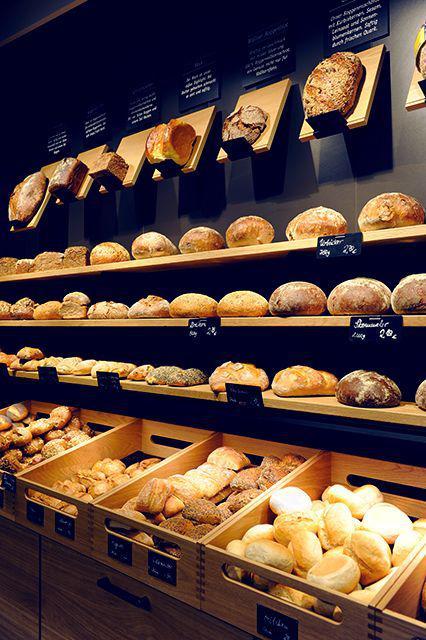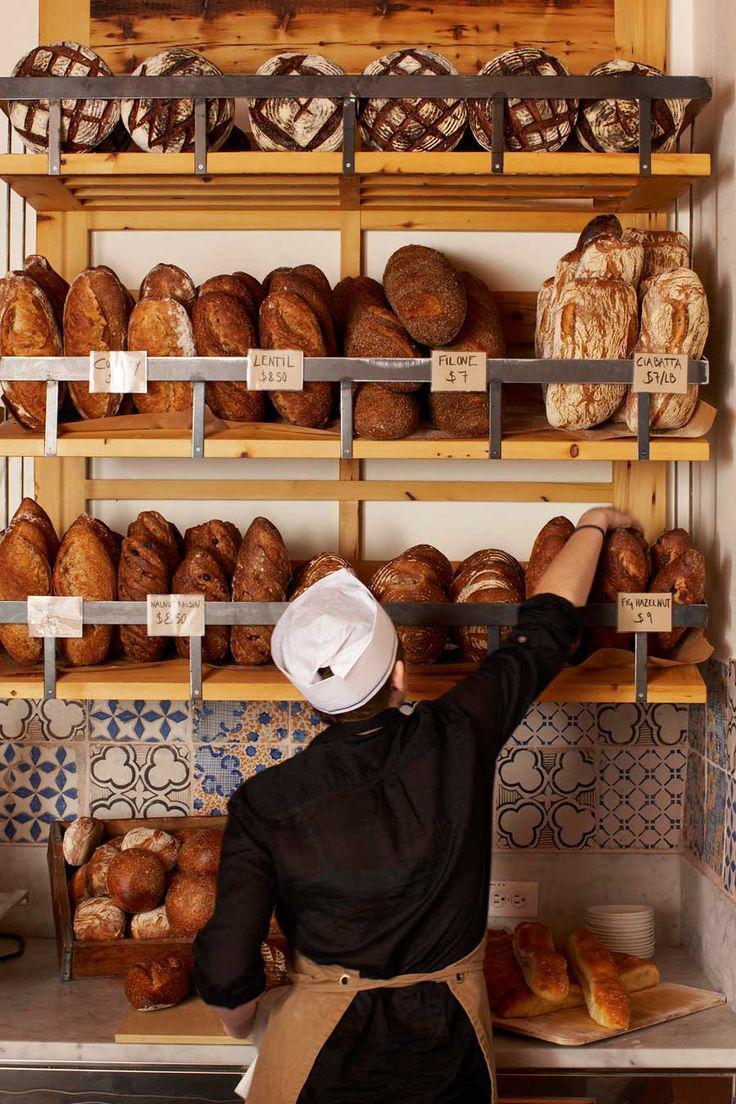The first image is the image on the left, the second image is the image on the right. Given the left and right images, does the statement "At least one image shows a uniformed bakery worker." hold true? Answer yes or no. Yes. The first image is the image on the left, the second image is the image on the right. Given the left and right images, does the statement "In 1 of the images, a person is near bread." hold true? Answer yes or no. Yes. 